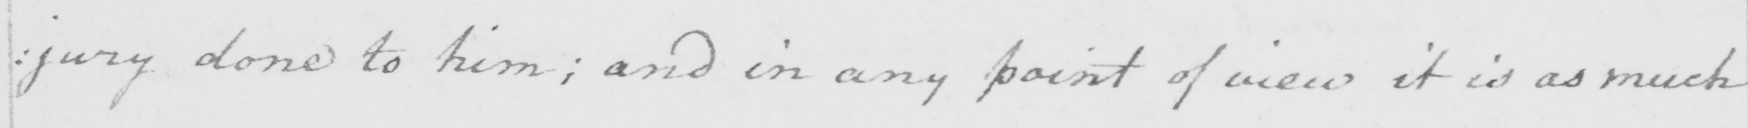What is written in this line of handwriting? : jury done to him ; and in any point of view it is as much 